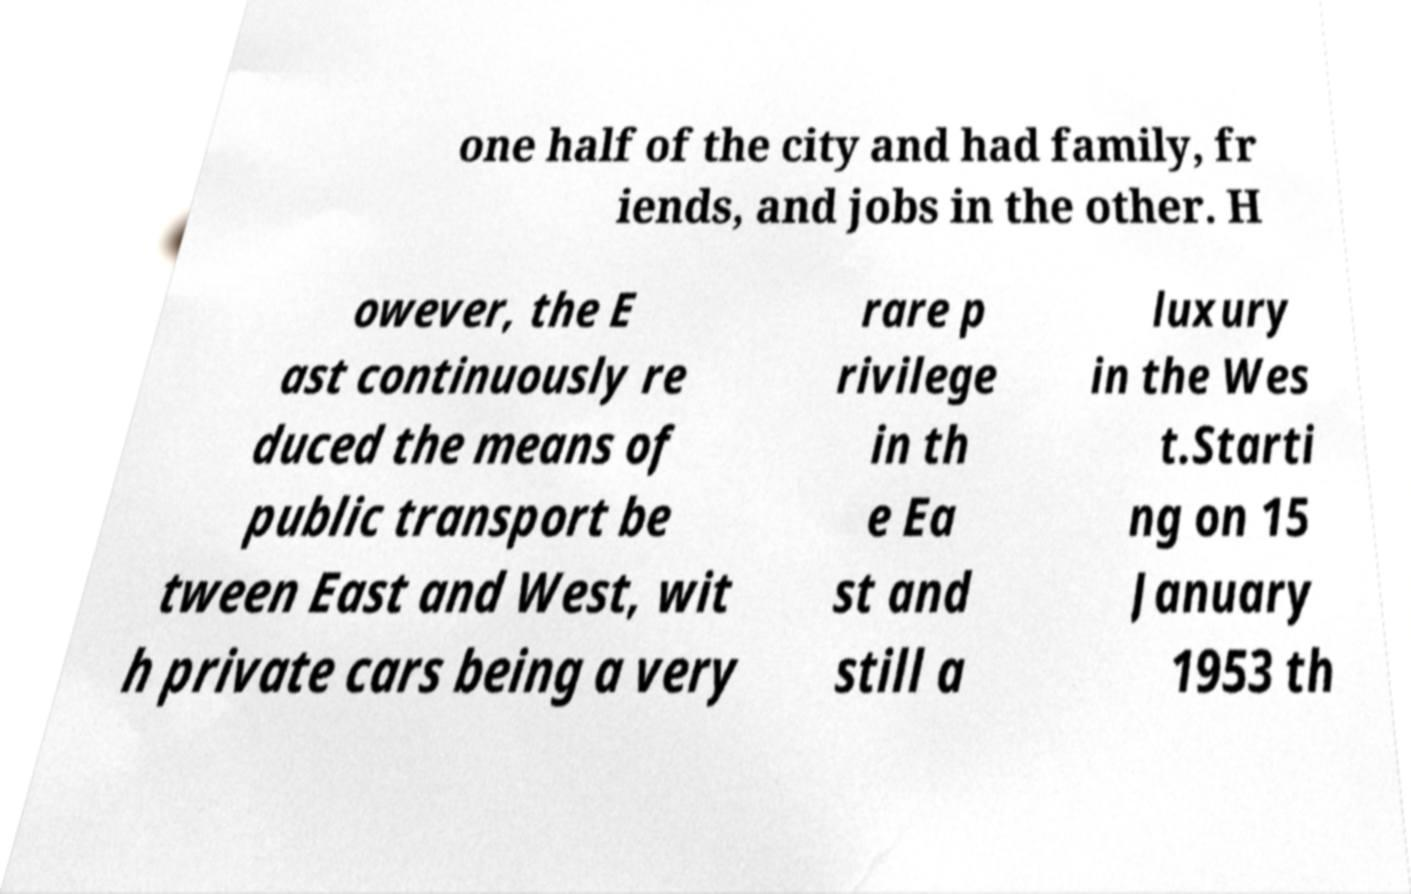Can you read and provide the text displayed in the image?This photo seems to have some interesting text. Can you extract and type it out for me? one half of the city and had family, fr iends, and jobs in the other. H owever, the E ast continuously re duced the means of public transport be tween East and West, wit h private cars being a very rare p rivilege in th e Ea st and still a luxury in the Wes t.Starti ng on 15 January 1953 th 